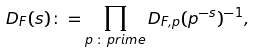Convert formula to latex. <formula><loc_0><loc_0><loc_500><loc_500>D _ { F } ( s ) \colon = \prod _ { p \, \colon \, p r i m e } D _ { F , p } ( p ^ { - s } ) ^ { - 1 } ,</formula> 